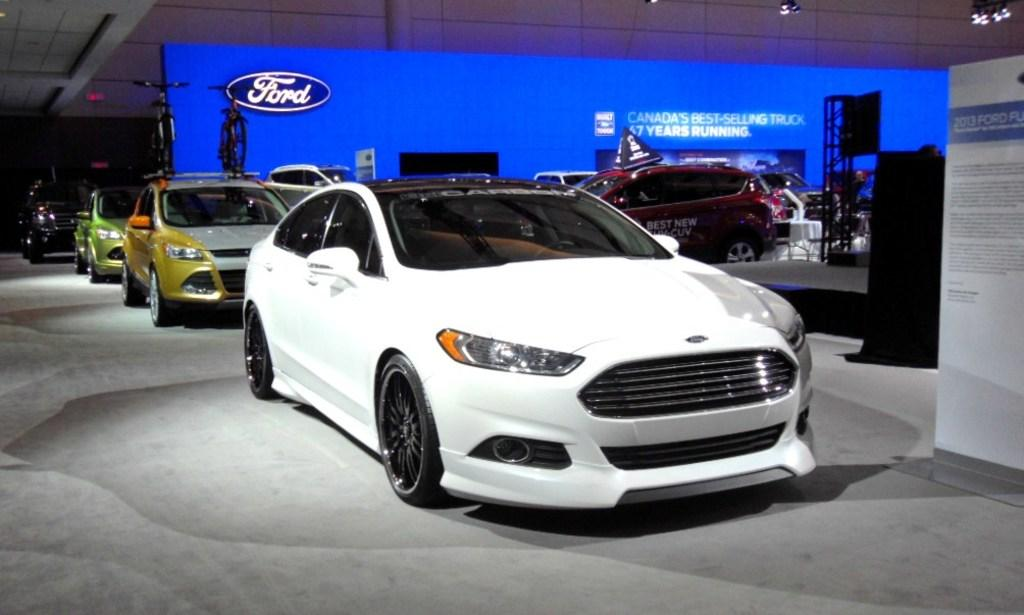What type of vehicles can be seen in the foreground of the image? There are cars in the foreground of the image. Where are the cars located in relation to the image? The cars are on the floor in the image. What is the color of the screen in the image? There is a blue screen in the image. What can be seen at the top of the image? There are lights at the top of the image. How many pairs of shoes can be seen in the image? There are no shoes visible in the image. What type of bears are interacting with the cars in the image? There are no bears present in the image. 